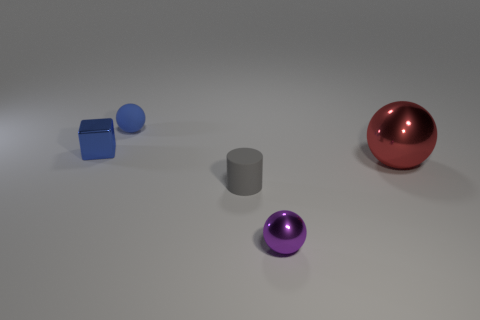Subtract all cyan spheres. Subtract all blue cylinders. How many spheres are left? 3 Add 1 big purple shiny objects. How many objects exist? 6 Subtract all cylinders. How many objects are left? 4 Subtract all small cyan objects. Subtract all gray cylinders. How many objects are left? 4 Add 3 small purple spheres. How many small purple spheres are left? 4 Add 2 matte cylinders. How many matte cylinders exist? 3 Subtract 0 red cylinders. How many objects are left? 5 